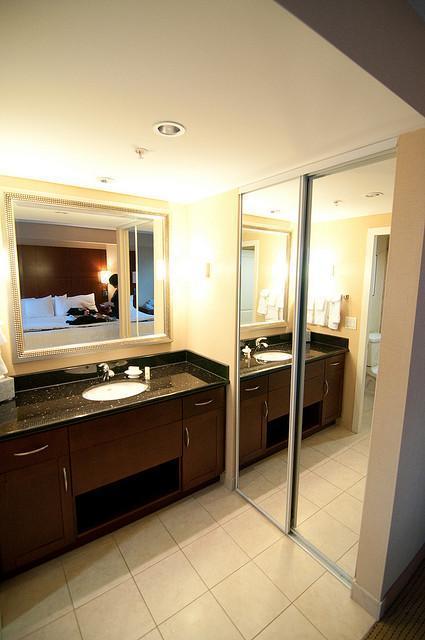What is behind the two tall mirrors?
Choose the right answer from the provided options to respond to the question.
Options: Bathroom, bedroom, closet, hallway. Closet. 